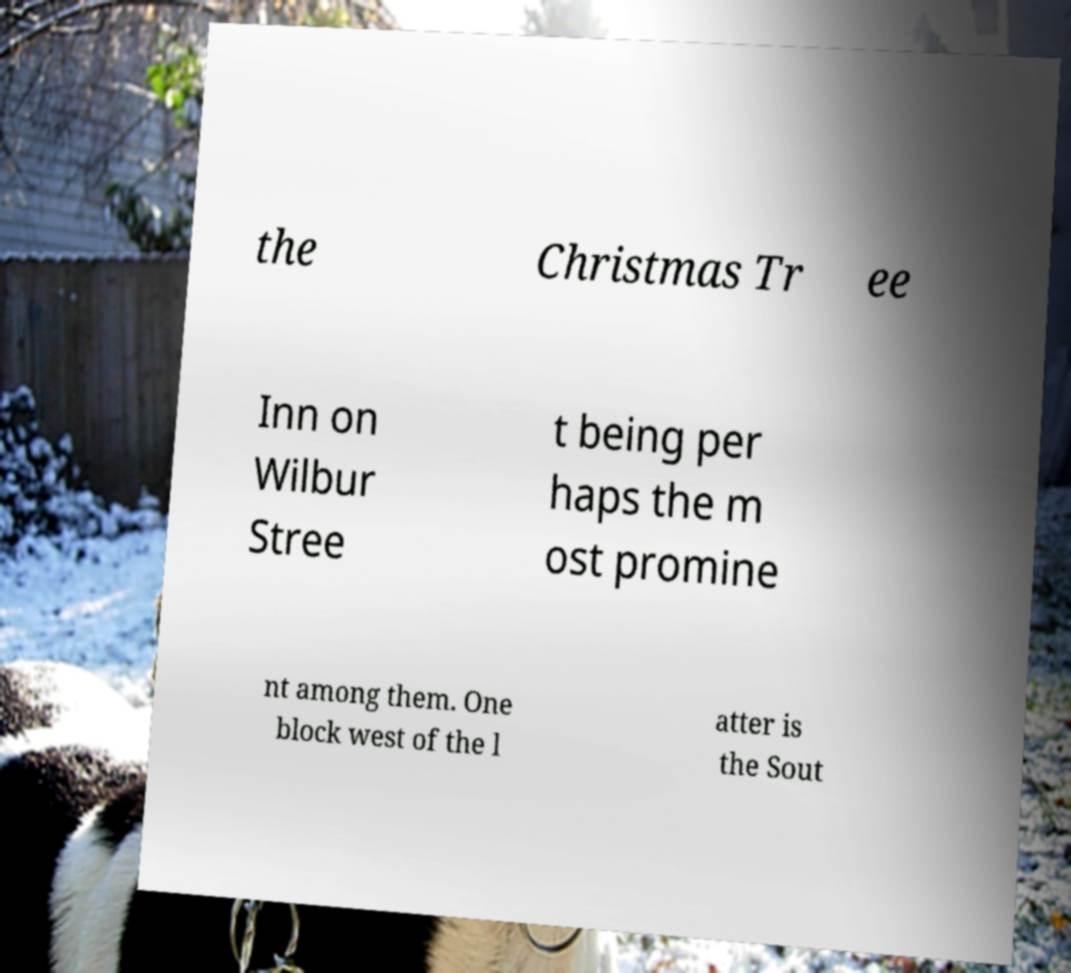Could you assist in decoding the text presented in this image and type it out clearly? the Christmas Tr ee Inn on Wilbur Stree t being per haps the m ost promine nt among them. One block west of the l atter is the Sout 